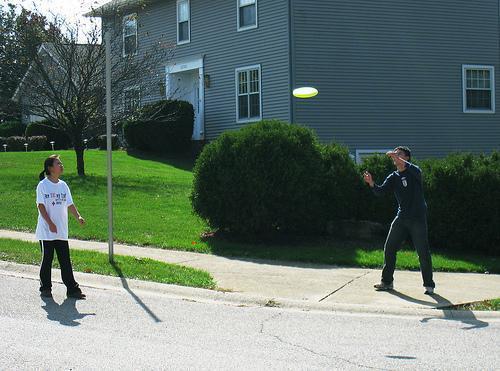How many people in the picture?
Give a very brief answer. 2. How many windows on the house?
Give a very brief answer. 6. 